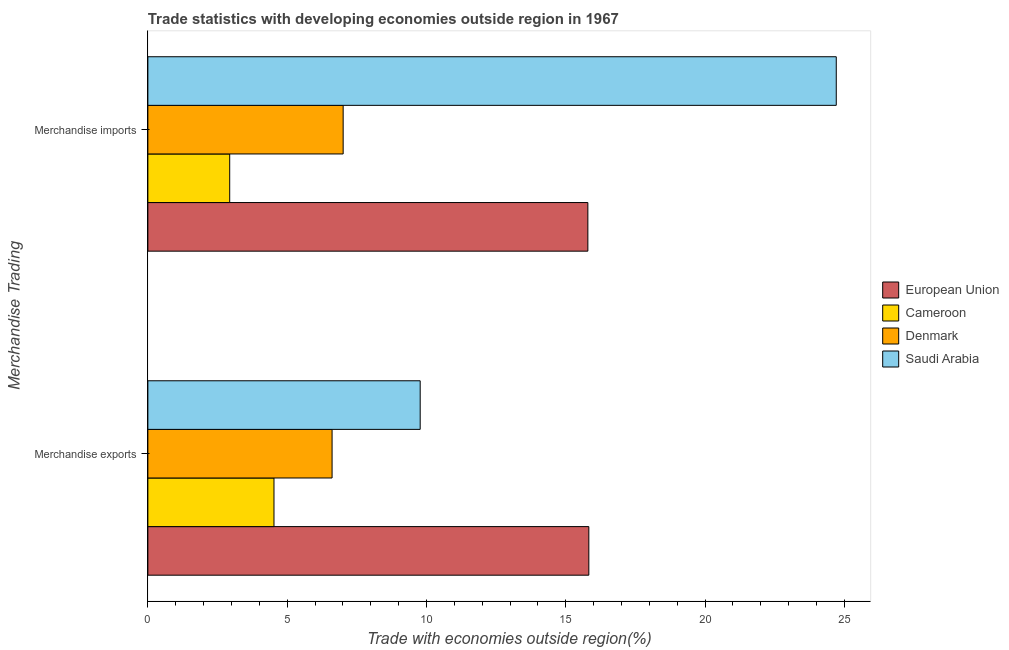Are the number of bars per tick equal to the number of legend labels?
Your answer should be compact. Yes. Are the number of bars on each tick of the Y-axis equal?
Make the answer very short. Yes. How many bars are there on the 2nd tick from the top?
Keep it short and to the point. 4. What is the label of the 2nd group of bars from the top?
Offer a very short reply. Merchandise exports. What is the merchandise imports in Cameroon?
Ensure brevity in your answer.  2.94. Across all countries, what is the maximum merchandise imports?
Provide a short and direct response. 24.71. Across all countries, what is the minimum merchandise imports?
Provide a short and direct response. 2.94. In which country was the merchandise imports maximum?
Your answer should be compact. Saudi Arabia. In which country was the merchandise imports minimum?
Your response must be concise. Cameroon. What is the total merchandise imports in the graph?
Give a very brief answer. 50.45. What is the difference between the merchandise exports in Cameroon and that in Saudi Arabia?
Your answer should be very brief. -5.25. What is the difference between the merchandise exports in European Union and the merchandise imports in Denmark?
Offer a terse response. 8.82. What is the average merchandise exports per country?
Your answer should be very brief. 9.19. What is the difference between the merchandise imports and merchandise exports in Saudi Arabia?
Offer a terse response. 14.94. What is the ratio of the merchandise exports in Cameroon to that in European Union?
Provide a short and direct response. 0.29. Is the merchandise imports in Cameroon less than that in Saudi Arabia?
Offer a terse response. Yes. What does the 1st bar from the top in Merchandise exports represents?
Give a very brief answer. Saudi Arabia. What does the 2nd bar from the bottom in Merchandise exports represents?
Your answer should be very brief. Cameroon. How many bars are there?
Keep it short and to the point. 8. Are all the bars in the graph horizontal?
Your answer should be compact. Yes. What is the difference between two consecutive major ticks on the X-axis?
Your answer should be compact. 5. Are the values on the major ticks of X-axis written in scientific E-notation?
Offer a very short reply. No. Where does the legend appear in the graph?
Your answer should be very brief. Center right. How many legend labels are there?
Give a very brief answer. 4. What is the title of the graph?
Offer a very short reply. Trade statistics with developing economies outside region in 1967. What is the label or title of the X-axis?
Ensure brevity in your answer.  Trade with economies outside region(%). What is the label or title of the Y-axis?
Your response must be concise. Merchandise Trading. What is the Trade with economies outside region(%) of European Union in Merchandise exports?
Your response must be concise. 15.83. What is the Trade with economies outside region(%) in Cameroon in Merchandise exports?
Provide a succinct answer. 4.53. What is the Trade with economies outside region(%) in Denmark in Merchandise exports?
Give a very brief answer. 6.61. What is the Trade with economies outside region(%) in Saudi Arabia in Merchandise exports?
Provide a succinct answer. 9.78. What is the Trade with economies outside region(%) in European Union in Merchandise imports?
Keep it short and to the point. 15.79. What is the Trade with economies outside region(%) in Cameroon in Merchandise imports?
Offer a very short reply. 2.94. What is the Trade with economies outside region(%) in Denmark in Merchandise imports?
Offer a terse response. 7.01. What is the Trade with economies outside region(%) in Saudi Arabia in Merchandise imports?
Give a very brief answer. 24.71. Across all Merchandise Trading, what is the maximum Trade with economies outside region(%) in European Union?
Provide a short and direct response. 15.83. Across all Merchandise Trading, what is the maximum Trade with economies outside region(%) of Cameroon?
Give a very brief answer. 4.53. Across all Merchandise Trading, what is the maximum Trade with economies outside region(%) of Denmark?
Your answer should be very brief. 7.01. Across all Merchandise Trading, what is the maximum Trade with economies outside region(%) in Saudi Arabia?
Provide a short and direct response. 24.71. Across all Merchandise Trading, what is the minimum Trade with economies outside region(%) of European Union?
Ensure brevity in your answer.  15.79. Across all Merchandise Trading, what is the minimum Trade with economies outside region(%) in Cameroon?
Ensure brevity in your answer.  2.94. Across all Merchandise Trading, what is the minimum Trade with economies outside region(%) of Denmark?
Make the answer very short. 6.61. Across all Merchandise Trading, what is the minimum Trade with economies outside region(%) in Saudi Arabia?
Provide a short and direct response. 9.78. What is the total Trade with economies outside region(%) of European Union in the graph?
Your answer should be very brief. 31.62. What is the total Trade with economies outside region(%) of Cameroon in the graph?
Make the answer very short. 7.47. What is the total Trade with economies outside region(%) of Denmark in the graph?
Keep it short and to the point. 13.62. What is the total Trade with economies outside region(%) in Saudi Arabia in the graph?
Keep it short and to the point. 34.49. What is the difference between the Trade with economies outside region(%) of European Union in Merchandise exports and that in Merchandise imports?
Ensure brevity in your answer.  0.03. What is the difference between the Trade with economies outside region(%) of Cameroon in Merchandise exports and that in Merchandise imports?
Offer a terse response. 1.59. What is the difference between the Trade with economies outside region(%) of Denmark in Merchandise exports and that in Merchandise imports?
Your answer should be compact. -0.4. What is the difference between the Trade with economies outside region(%) of Saudi Arabia in Merchandise exports and that in Merchandise imports?
Give a very brief answer. -14.94. What is the difference between the Trade with economies outside region(%) in European Union in Merchandise exports and the Trade with economies outside region(%) in Cameroon in Merchandise imports?
Your response must be concise. 12.89. What is the difference between the Trade with economies outside region(%) of European Union in Merchandise exports and the Trade with economies outside region(%) of Denmark in Merchandise imports?
Your answer should be very brief. 8.82. What is the difference between the Trade with economies outside region(%) in European Union in Merchandise exports and the Trade with economies outside region(%) in Saudi Arabia in Merchandise imports?
Offer a terse response. -8.88. What is the difference between the Trade with economies outside region(%) of Cameroon in Merchandise exports and the Trade with economies outside region(%) of Denmark in Merchandise imports?
Your response must be concise. -2.48. What is the difference between the Trade with economies outside region(%) of Cameroon in Merchandise exports and the Trade with economies outside region(%) of Saudi Arabia in Merchandise imports?
Make the answer very short. -20.18. What is the difference between the Trade with economies outside region(%) in Denmark in Merchandise exports and the Trade with economies outside region(%) in Saudi Arabia in Merchandise imports?
Your answer should be compact. -18.1. What is the average Trade with economies outside region(%) of European Union per Merchandise Trading?
Your answer should be very brief. 15.81. What is the average Trade with economies outside region(%) in Cameroon per Merchandise Trading?
Keep it short and to the point. 3.73. What is the average Trade with economies outside region(%) of Denmark per Merchandise Trading?
Provide a succinct answer. 6.81. What is the average Trade with economies outside region(%) in Saudi Arabia per Merchandise Trading?
Offer a terse response. 17.24. What is the difference between the Trade with economies outside region(%) of European Union and Trade with economies outside region(%) of Cameroon in Merchandise exports?
Your answer should be very brief. 11.3. What is the difference between the Trade with economies outside region(%) in European Union and Trade with economies outside region(%) in Denmark in Merchandise exports?
Your answer should be very brief. 9.22. What is the difference between the Trade with economies outside region(%) in European Union and Trade with economies outside region(%) in Saudi Arabia in Merchandise exports?
Offer a very short reply. 6.05. What is the difference between the Trade with economies outside region(%) of Cameroon and Trade with economies outside region(%) of Denmark in Merchandise exports?
Provide a short and direct response. -2.09. What is the difference between the Trade with economies outside region(%) of Cameroon and Trade with economies outside region(%) of Saudi Arabia in Merchandise exports?
Keep it short and to the point. -5.25. What is the difference between the Trade with economies outside region(%) in Denmark and Trade with economies outside region(%) in Saudi Arabia in Merchandise exports?
Offer a terse response. -3.16. What is the difference between the Trade with economies outside region(%) in European Union and Trade with economies outside region(%) in Cameroon in Merchandise imports?
Your answer should be compact. 12.86. What is the difference between the Trade with economies outside region(%) of European Union and Trade with economies outside region(%) of Denmark in Merchandise imports?
Offer a terse response. 8.78. What is the difference between the Trade with economies outside region(%) in European Union and Trade with economies outside region(%) in Saudi Arabia in Merchandise imports?
Your answer should be compact. -8.92. What is the difference between the Trade with economies outside region(%) of Cameroon and Trade with economies outside region(%) of Denmark in Merchandise imports?
Offer a terse response. -4.07. What is the difference between the Trade with economies outside region(%) of Cameroon and Trade with economies outside region(%) of Saudi Arabia in Merchandise imports?
Provide a short and direct response. -21.77. What is the difference between the Trade with economies outside region(%) of Denmark and Trade with economies outside region(%) of Saudi Arabia in Merchandise imports?
Your response must be concise. -17.7. What is the ratio of the Trade with economies outside region(%) in European Union in Merchandise exports to that in Merchandise imports?
Provide a succinct answer. 1. What is the ratio of the Trade with economies outside region(%) of Cameroon in Merchandise exports to that in Merchandise imports?
Your response must be concise. 1.54. What is the ratio of the Trade with economies outside region(%) of Denmark in Merchandise exports to that in Merchandise imports?
Give a very brief answer. 0.94. What is the ratio of the Trade with economies outside region(%) in Saudi Arabia in Merchandise exports to that in Merchandise imports?
Keep it short and to the point. 0.4. What is the difference between the highest and the second highest Trade with economies outside region(%) of European Union?
Offer a very short reply. 0.03. What is the difference between the highest and the second highest Trade with economies outside region(%) in Cameroon?
Give a very brief answer. 1.59. What is the difference between the highest and the second highest Trade with economies outside region(%) of Denmark?
Provide a succinct answer. 0.4. What is the difference between the highest and the second highest Trade with economies outside region(%) in Saudi Arabia?
Keep it short and to the point. 14.94. What is the difference between the highest and the lowest Trade with economies outside region(%) in European Union?
Provide a succinct answer. 0.03. What is the difference between the highest and the lowest Trade with economies outside region(%) of Cameroon?
Make the answer very short. 1.59. What is the difference between the highest and the lowest Trade with economies outside region(%) of Denmark?
Provide a short and direct response. 0.4. What is the difference between the highest and the lowest Trade with economies outside region(%) of Saudi Arabia?
Your answer should be compact. 14.94. 